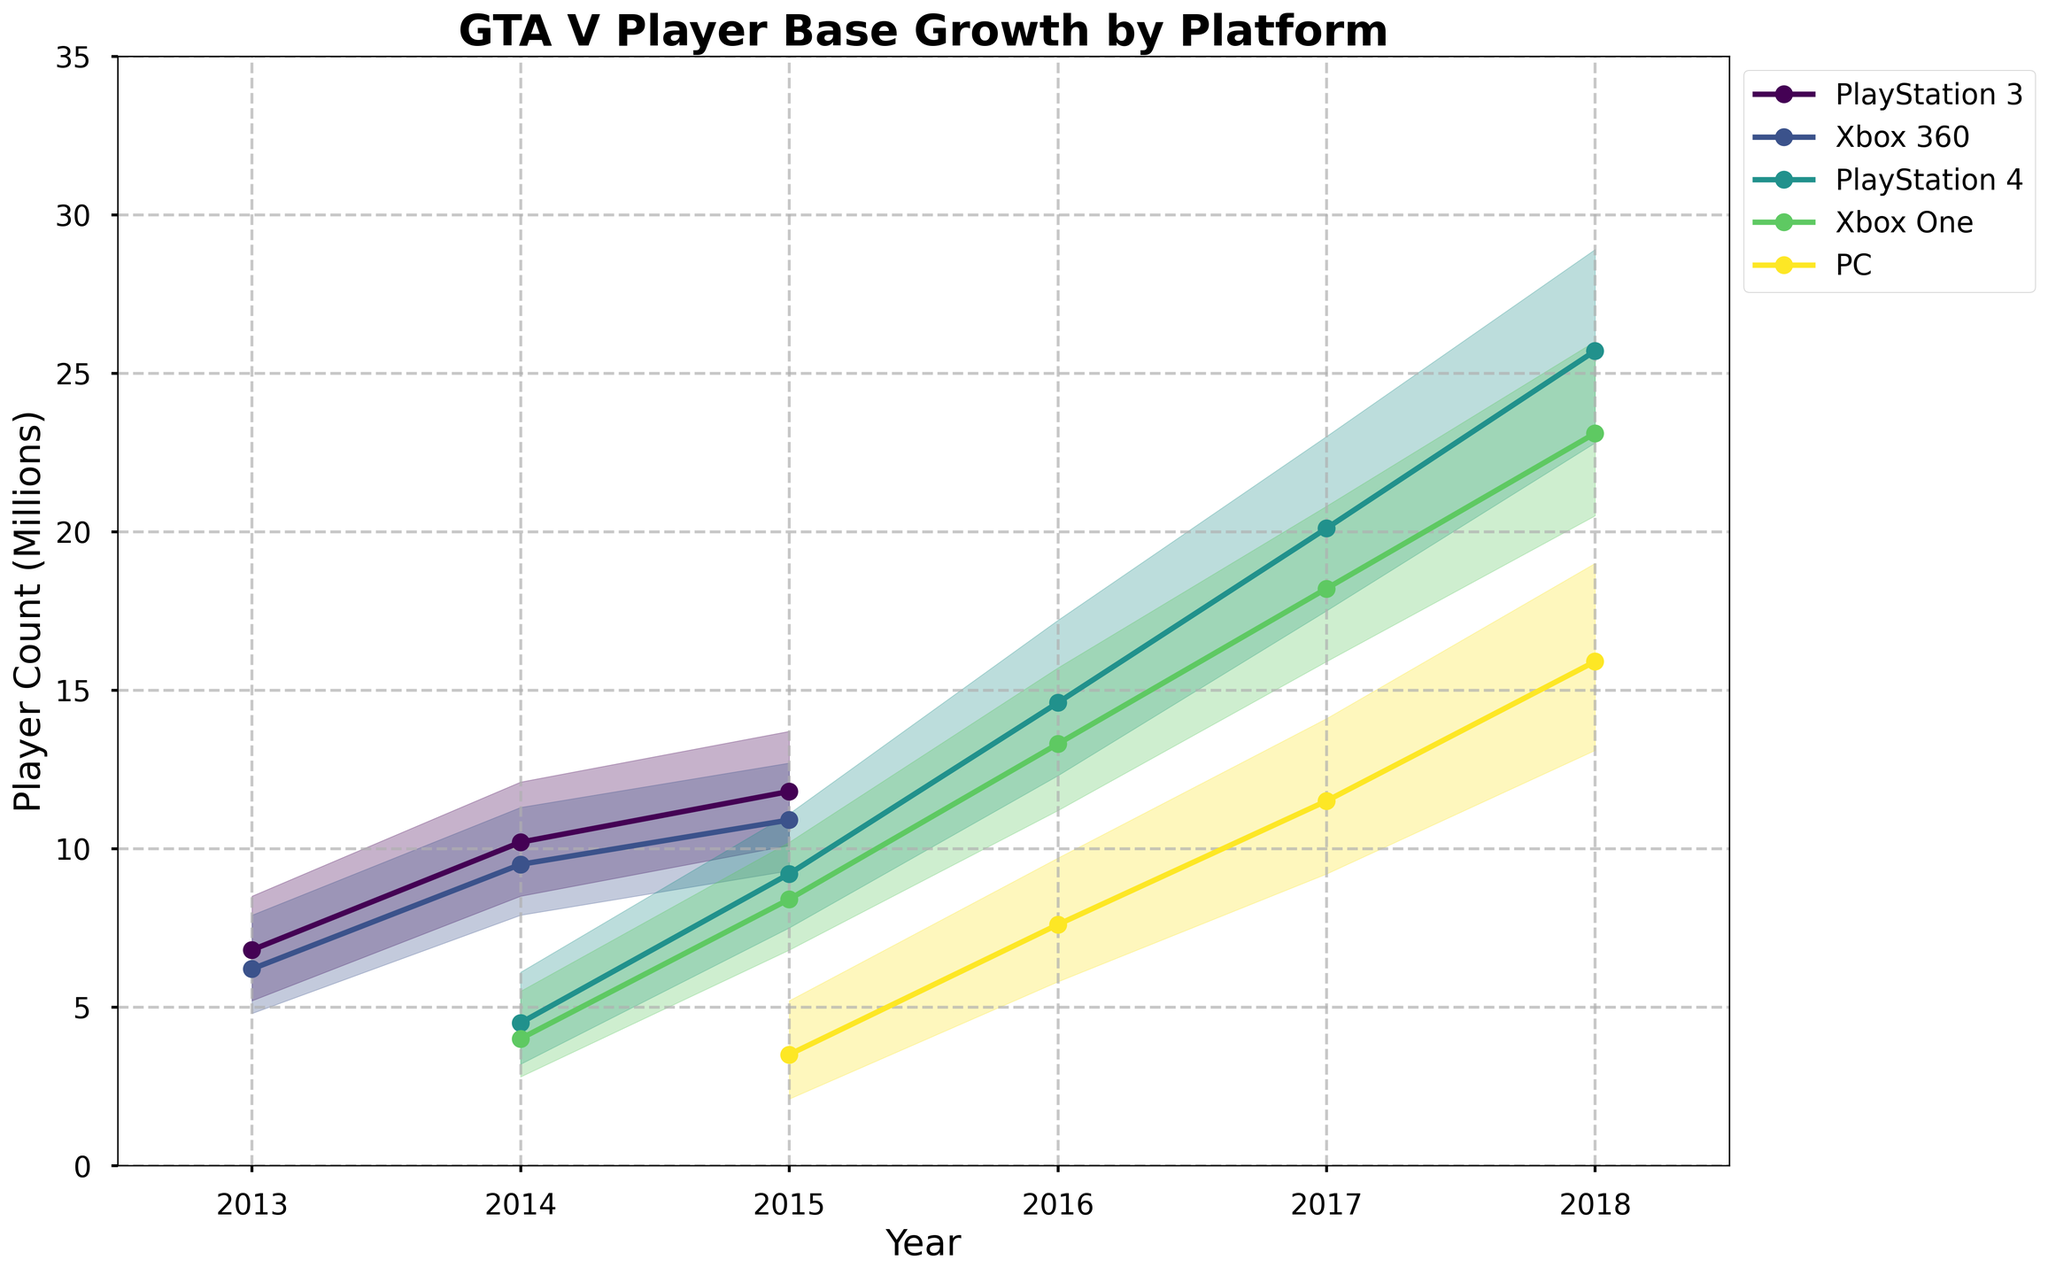What is the title of the figure? The title of the figure is displayed at the top of the chart in large font.
Answer: GTA V Player Base Growth by Platform Which platform had the highest median player base in 2018? Looking at the median line for each platform in 2018, the PlayStation 4 has the highest median player count compared to Xbox One and PC.
Answer: PlayStation 4 In which year did the PC platform start to appear in the data? By examining the x-axis and the data lines, the PC platform first appears in 2015.
Answer: 2015 Which platform experienced the fastest growth from 2014 to 2015 in terms of median player count? Subtract the median values for each platform from 2014 to 2015, and observe the difference. PlayStation 4 increased from 4.5 to 9.2 million, which is the largest growth among the platforms.
Answer: PlayStation 4 What is the approximate range of the player count for the Xbox 360 platform in 2014? The range can be determined by subtracting the low value from the high value for Xbox 360 in 2014. The range is approximately from 7.9 to 11.3 million.
Answer: 7.9 to 11.3 million Which platform had the smallest player base in 2015? Compare the median values of all platforms in 2015. The PC, with a median of 3.5 million, had the smallest player base that year.
Answer: PC How did the Xbox One median player count change from 2016 to 2017? By evaluating the median values for Xbox One in 2016 and 2017, the median player count increased from 13.3 million to 18.2 million.
Answer: Increased by 4.9 million What is the difference between the highest median player counts for PC and Xbox One in 2017? Subtract the median player count of PC (11.5 million) from the Xbox One (18.2 million) in 2017. The difference is 18.2 - 11.5 = 6.7 million.
Answer: 6.7 million Which year had the highest overall player base across all platforms when considering median values? Calculate the sum of median values for all platforms in each year and compare. 2018 has the highest overall player base when summing the medians.
Answer: 2018 